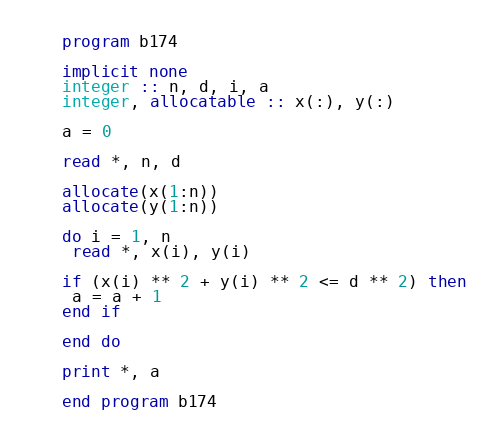Convert code to text. <code><loc_0><loc_0><loc_500><loc_500><_FORTRAN_>program b174

implicit none
integer :: n, d, i, a
integer, allocatable :: x(:), y(:)

a = 0

read *, n, d

allocate(x(1:n))
allocate(y(1:n))

do i = 1, n
 read *, x(i), y(i)

if (x(i) ** 2 + y(i) ** 2 <= d ** 2) then
 a = a + 1
end if

end do

print *, a

end program b174</code> 